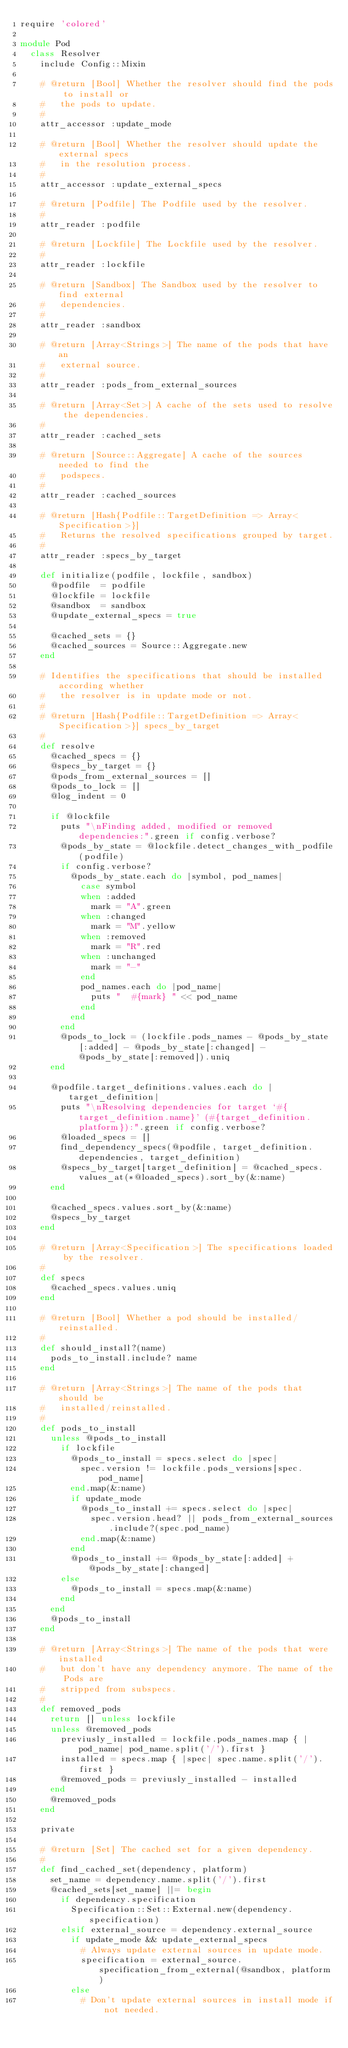Convert code to text. <code><loc_0><loc_0><loc_500><loc_500><_Ruby_>require 'colored'

module Pod
  class Resolver
    include Config::Mixin

    # @return [Bool] Whether the resolver should find the pods to install or
    #   the pods to update.
    #
    attr_accessor :update_mode

    # @return [Bool] Whether the resolver should update the external specs
    #   in the resolution process.
    #
    attr_accessor :update_external_specs

    # @return [Podfile] The Podfile used by the resolver.
    #
    attr_reader :podfile

    # @return [Lockfile] The Lockfile used by the resolver.
    #
    attr_reader :lockfile

    # @return [Sandbox] The Sandbox used by the resolver to find external
    #   dependencies.
    #
    attr_reader :sandbox

    # @return [Array<Strings>] The name of the pods that have an
    #   external source.
    #
    attr_reader :pods_from_external_sources

    # @return [Array<Set>] A cache of the sets used to resolve the dependencies.
    #
    attr_reader :cached_sets

    # @return [Source::Aggregate] A cache of the sources needed to find the
    #   podspecs.
    #
    attr_reader :cached_sources

    # @return [Hash{Podfile::TargetDefinition => Array<Specification>}]
    #   Returns the resolved specifications grouped by target.
    #
    attr_reader :specs_by_target

    def initialize(podfile, lockfile, sandbox)
      @podfile  = podfile
      @lockfile = lockfile
      @sandbox  = sandbox
      @update_external_specs = true

      @cached_sets = {}
      @cached_sources = Source::Aggregate.new
    end

    # Identifies the specifications that should be installed according whether
    #   the resolver is in update mode or not.
    #
    # @return [Hash{Podfile::TargetDefinition => Array<Specification>}] specs_by_target
    #
    def resolve
      @cached_specs = {}
      @specs_by_target = {}
      @pods_from_external_sources = []
      @pods_to_lock = []
      @log_indent = 0

      if @lockfile
        puts "\nFinding added, modified or removed dependencies:".green if config.verbose?
        @pods_by_state = @lockfile.detect_changes_with_podfile(podfile)
        if config.verbose?
          @pods_by_state.each do |symbol, pod_names|
            case symbol
            when :added
              mark = "A".green
            when :changed
              mark = "M".yellow
            when :removed
              mark = "R".red
            when :unchanged
              mark = "-"
            end
            pod_names.each do |pod_name|
              puts "  #{mark} " << pod_name
            end
          end
        end
        @pods_to_lock = (lockfile.pods_names - @pods_by_state[:added] - @pods_by_state[:changed] - @pods_by_state[:removed]).uniq
      end

      @podfile.target_definitions.values.each do |target_definition|
        puts "\nResolving dependencies for target `#{target_definition.name}' (#{target_definition.platform}):".green if config.verbose?
        @loaded_specs = []
        find_dependency_specs(@podfile, target_definition.dependencies, target_definition)
        @specs_by_target[target_definition] = @cached_specs.values_at(*@loaded_specs).sort_by(&:name)
      end

      @cached_specs.values.sort_by(&:name)
      @specs_by_target
    end

    # @return [Array<Specification>] The specifications loaded by the resolver.
    #
    def specs
      @cached_specs.values.uniq
    end

    # @return [Bool] Whether a pod should be installed/reinstalled.
    #
    def should_install?(name)
      pods_to_install.include? name
    end

    # @return [Array<Strings>] The name of the pods that should be
    #   installed/reinstalled.
    #
    def pods_to_install
      unless @pods_to_install
        if lockfile
          @pods_to_install = specs.select do |spec|
            spec.version != lockfile.pods_versions[spec.pod_name]
          end.map(&:name)
          if update_mode
            @pods_to_install += specs.select do |spec|
              spec.version.head? || pods_from_external_sources.include?(spec.pod_name)
            end.map(&:name)
          end
          @pods_to_install += @pods_by_state[:added] + @pods_by_state[:changed]
        else
          @pods_to_install = specs.map(&:name)
        end
      end
      @pods_to_install
    end

    # @return [Array<Strings>] The name of the pods that were installed
    #   but don't have any dependency anymore. The name of the Pods are
    #   stripped from subspecs.
    #
    def removed_pods
      return [] unless lockfile
      unless @removed_pods
        previusly_installed = lockfile.pods_names.map { |pod_name| pod_name.split('/').first }
        installed = specs.map { |spec| spec.name.split('/').first }
        @removed_pods = previusly_installed - installed
      end
      @removed_pods
    end

    private

    # @return [Set] The cached set for a given dependency.
    #
    def find_cached_set(dependency, platform)
      set_name = dependency.name.split('/').first
      @cached_sets[set_name] ||= begin
        if dependency.specification
          Specification::Set::External.new(dependency.specification)
        elsif external_source = dependency.external_source
          if update_mode && update_external_specs
            # Always update external sources in update mode.
            specification = external_source.specification_from_external(@sandbox, platform)
          else
            # Don't update external sources in install mode if not needed.</code> 